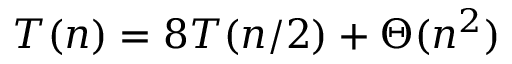<formula> <loc_0><loc_0><loc_500><loc_500>T ( n ) = 8 T ( n / 2 ) + \Theta ( n ^ { 2 } )</formula> 